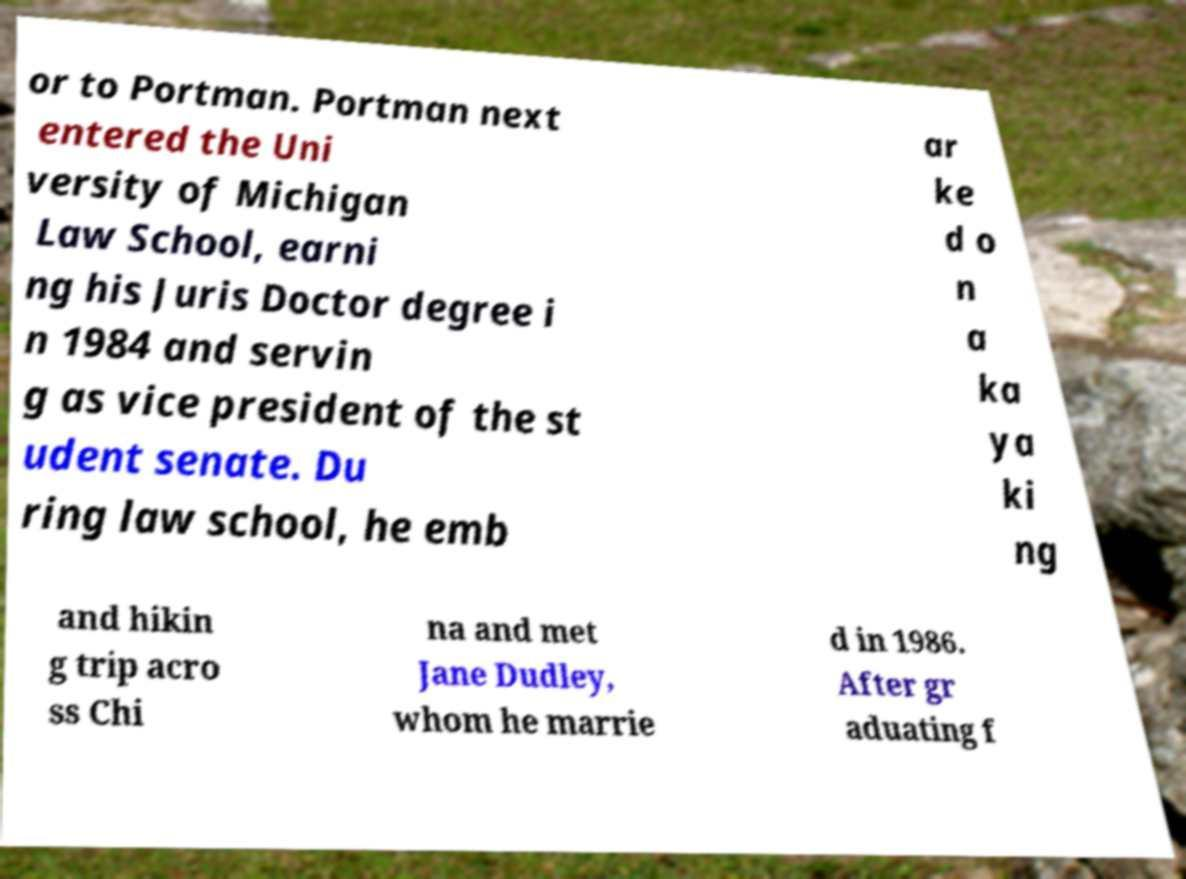There's text embedded in this image that I need extracted. Can you transcribe it verbatim? or to Portman. Portman next entered the Uni versity of Michigan Law School, earni ng his Juris Doctor degree i n 1984 and servin g as vice president of the st udent senate. Du ring law school, he emb ar ke d o n a ka ya ki ng and hikin g trip acro ss Chi na and met Jane Dudley, whom he marrie d in 1986. After gr aduating f 